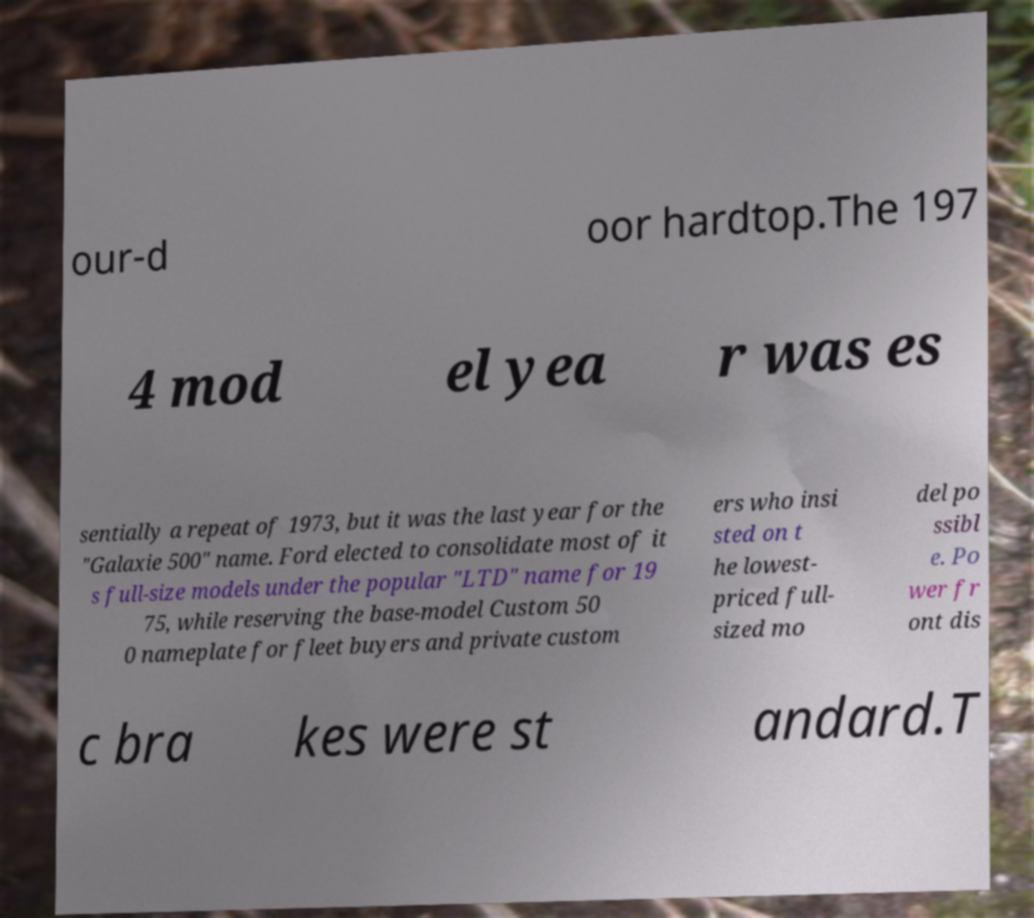What messages or text are displayed in this image? I need them in a readable, typed format. our-d oor hardtop.The 197 4 mod el yea r was es sentially a repeat of 1973, but it was the last year for the "Galaxie 500" name. Ford elected to consolidate most of it s full-size models under the popular "LTD" name for 19 75, while reserving the base-model Custom 50 0 nameplate for fleet buyers and private custom ers who insi sted on t he lowest- priced full- sized mo del po ssibl e. Po wer fr ont dis c bra kes were st andard.T 